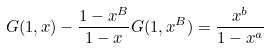Convert formula to latex. <formula><loc_0><loc_0><loc_500><loc_500>G ( 1 , x ) - \frac { 1 - x ^ { B } } { 1 - x } G ( 1 , x ^ { B } ) = \frac { x ^ { b } } { 1 - x ^ { a } }</formula> 